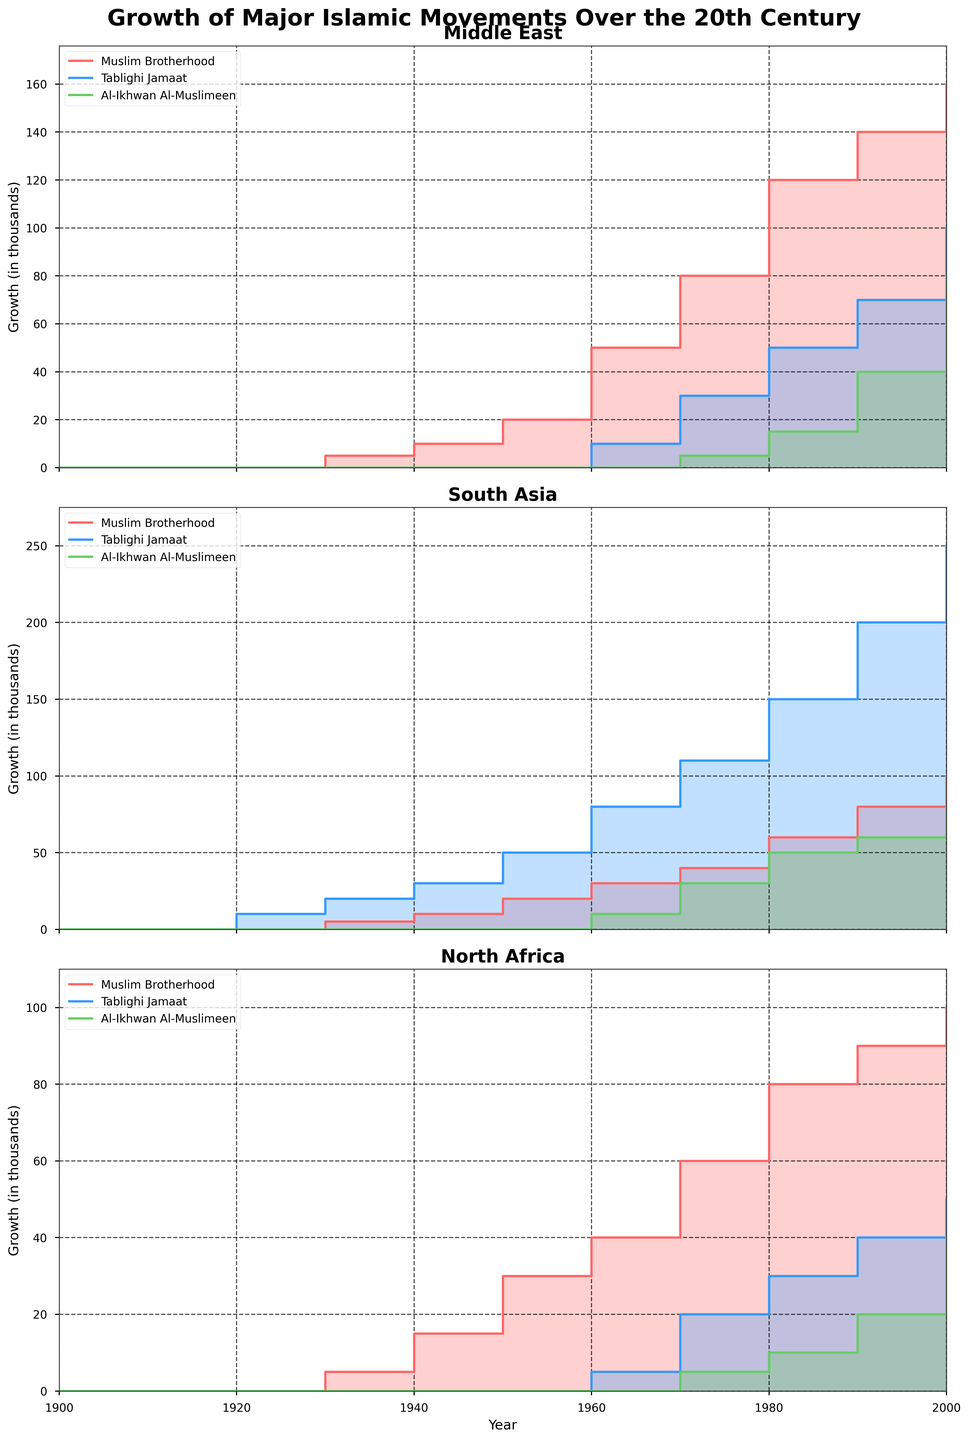What is the title of the figure? The title is often located at the top of a figure to give an overall description of what is being displayed. For this figure, it is prominently displayed right at the top in bold.
Answer: Growth of Major Islamic Movements Over the 20th Century Which region shows the highest growth for the Muslim Brotherhood by the year 2000? By examining the step area charts, we compare the top values for the Muslim Brotherhood in each region. For the year 2000, the chart shows that the Muslim Brotherhood has its highest value in the Middle East region.
Answer: Middle East How did the growth of Tablighi Jamaat in North Africa change from 1960 to 1970? We look for the values of Tablighi Jamaat in North Africa for the years 1960 and 1970. The value increases from 5 in 1960 to 20 in 1970 indicating a growth.
Answer: Increased from 5 to 20 Which movement shows the second highest growth in South Asia in 1980? We glance at the step values for South Asia in 1980. The Tablighi Jamaat has the highest growth, while Al-Ikhwan Al-Muslimeen has noticeably lower growth compared to Muslim Brotherhood, making Muslim Brotherhood the second highest.
Answer: Muslim Brotherhood Across all regions, which movement showed the smallest growth by the year 2000? By comparing the terminal (year 2000) values of all movements across the three regions, Al-Ikhwan Al-Muslimeen consistently has the smallest end value in each region.
Answer: Al-Ikhwan Al-Muslimeen What is the combined growth value of Tablighi Jamaat in all regions for the year 1990? We add the Tablighi Jamaat values for the year 1990 across Middle East, South Asia, and North Africa: 70 (Middle East) + 200 (South Asia) + 40 (North Africa) giving a total of 310.
Answer: 310 Between 1930 and 1980, which movement in the Middle East showed a growth of more than 100? We review the step data for Muslim Brotherhood, Tablighi Jamaat, and Al-Ikhwan Al-Muslimeen in Middle East. Muslim Brotherhood grows from 5 in 1930 to 120 in 1980 (a growth of 115), which exceeds 100.
Answer: Muslim Brotherhood In which region does Al-Ikhwan Al-Muslimeen show a visible increase starting only from 1970? Observing the step area charts, Al-Ikhwan Al-Muslimeen in the Middle East shows a visible increase starting from 1970 and not earlier in Middle East.
Answer: Middle East By how much did the Muslim Brotherhood in North Africa grow from 1940 to 1950? In the North Africa region, the Muslim Brotherhood values grow from 15 in 1940 to 30 in 1950. The difference is calculated as 30 - 15 = 15.
Answer: 15 